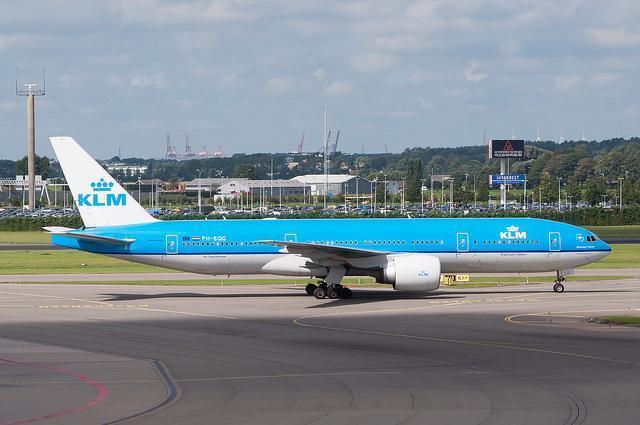How many zebras are in the picture?
Give a very brief answer. 0. 